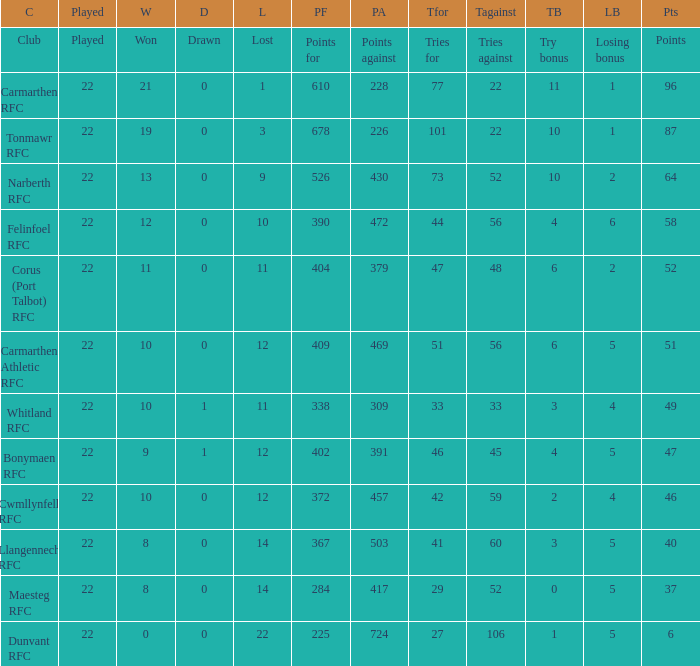Name the tries against for 87 points 22.0. 